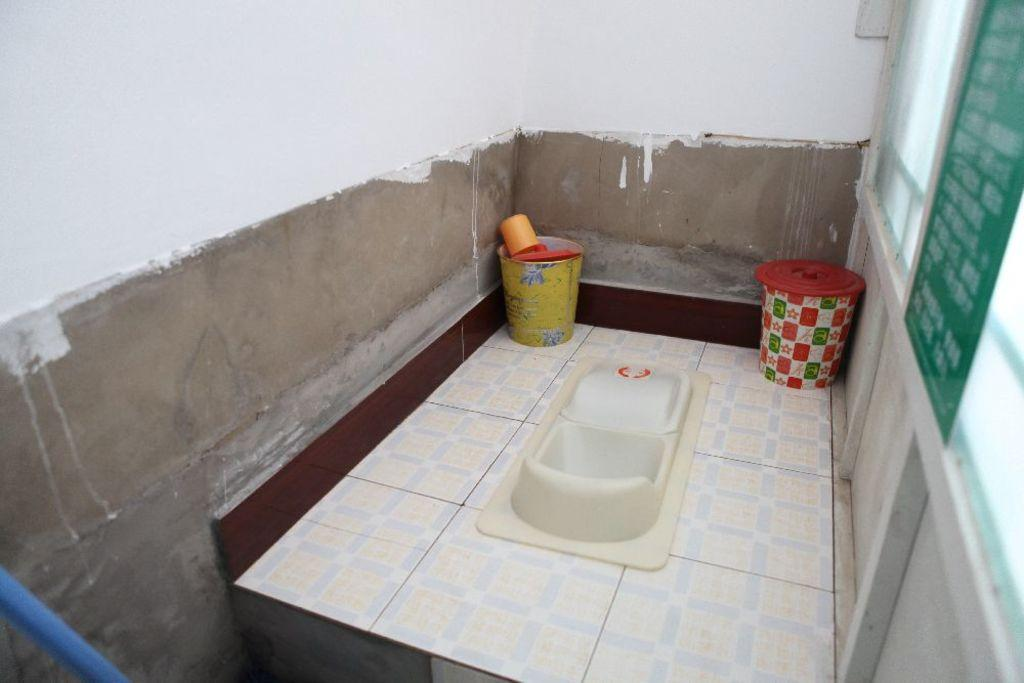What type of room is shown in the image? The image shows an inside view of a bathroom. What is one of the main fixtures in a bathroom that can be seen in the image? There is a commode in the image. What type of container is present in the image? There are bins in the image. What type of transport is visible in the image? There is no transport visible in the image, as it is an inside view of a bathroom. What type of metal is used to make the science equipment in the image? There is no science equipment or metal visible in the image. 